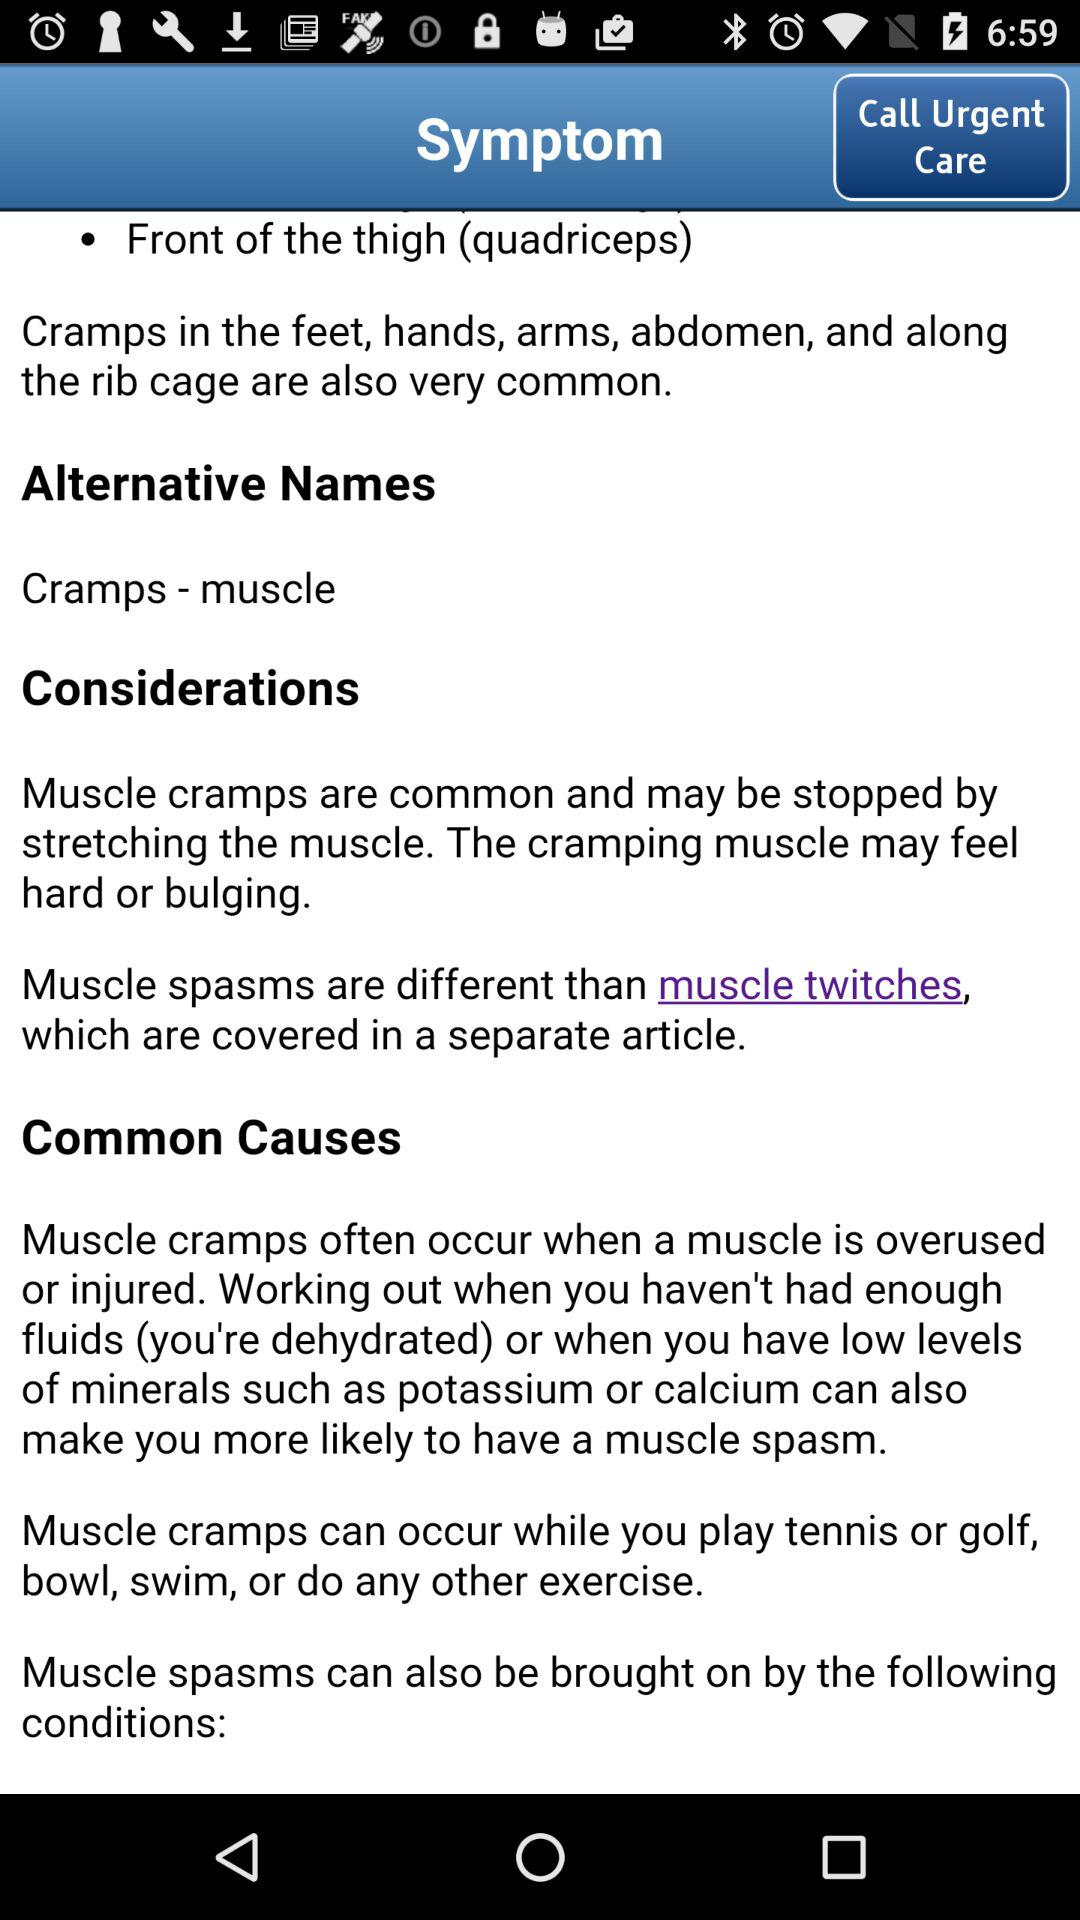What are the alternative names? The alternative name is "Cramps - muscle". 